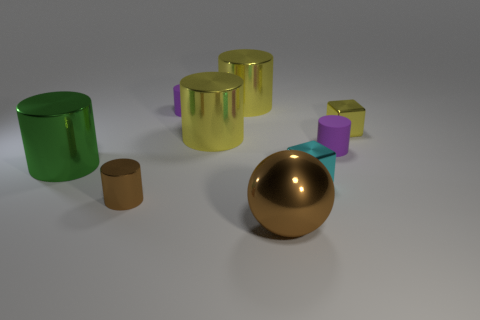Is the number of big metal objects less than the number of big green metallic cylinders?
Provide a succinct answer. No. What number of cylinders are either cyan objects or small matte objects?
Keep it short and to the point. 2. How many metal objects have the same color as the metallic sphere?
Offer a very short reply. 1. What is the size of the thing that is in front of the big green cylinder and behind the tiny brown metal cylinder?
Ensure brevity in your answer.  Small. Are there fewer brown cylinders to the right of the ball than brown balls?
Offer a terse response. Yes. Is the green object made of the same material as the small brown cylinder?
Your answer should be very brief. Yes. How many objects are either purple rubber things or large cylinders?
Offer a terse response. 5. What number of cylinders have the same material as the tiny brown thing?
Keep it short and to the point. 3. What size is the green thing that is the same shape as the tiny brown object?
Provide a short and direct response. Large. There is a tiny yellow cube; are there any large cylinders behind it?
Keep it short and to the point. Yes. 